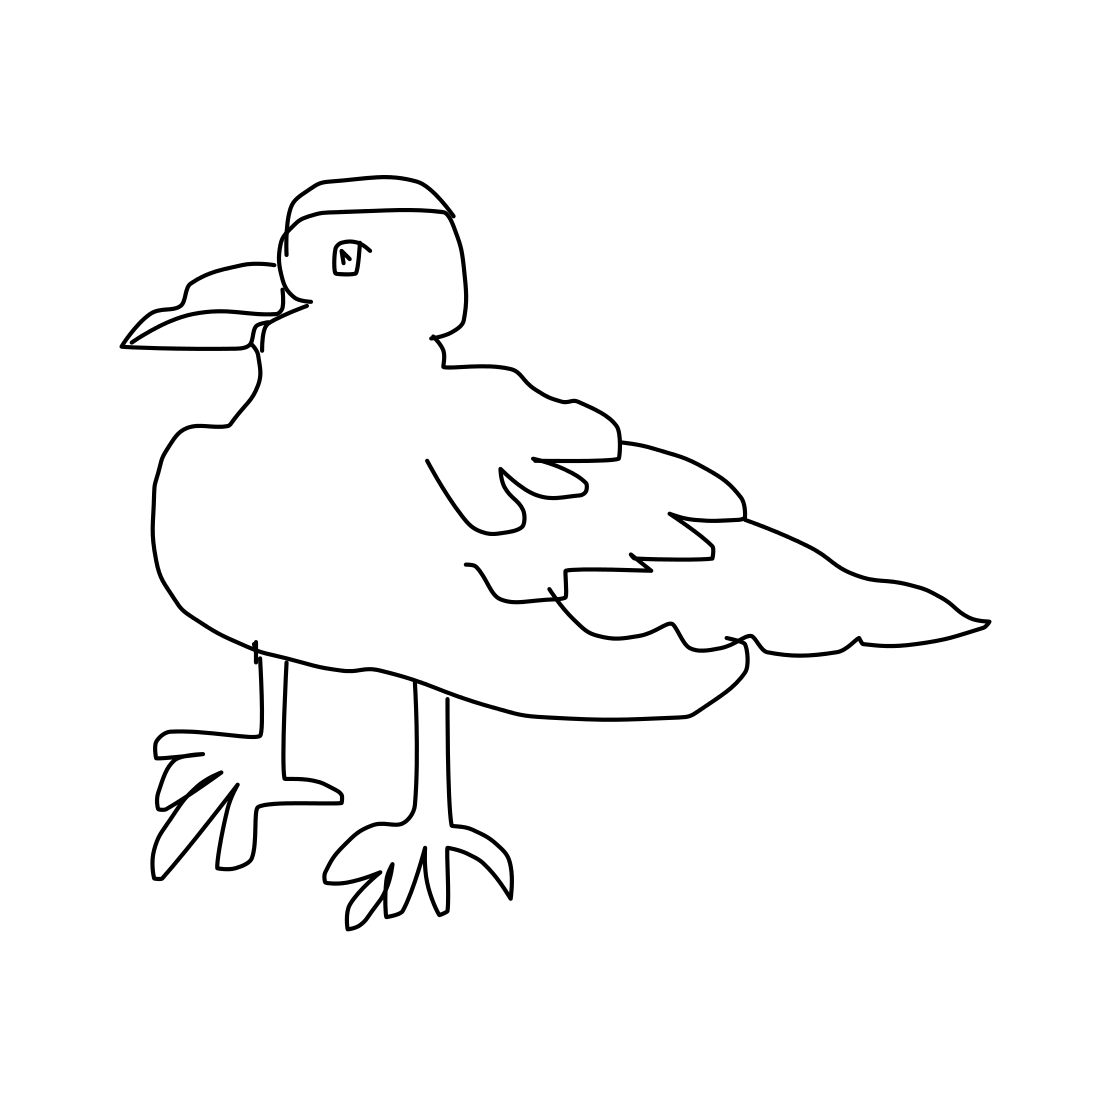What kind of environment do you think this bird might live in? Considering the bird's physical traits, such as its webbed feet and shape of the beak, it likely thrives in a coastal or marine environment. These adaptations suggest it might feed on fish or small aquatic creatures. Is there any significance to the style of the drawing? The line drawing style of the bird image offers a clean, minimalist aesthetic that accentuates the bird's key anatomical features. This style can be effective for educational purposes, making it easier for viewers to recognize and remember the bird's distinguishing traits. 